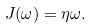Convert formula to latex. <formula><loc_0><loc_0><loc_500><loc_500>J ( \omega ) = { \eta } { \omega } .</formula> 